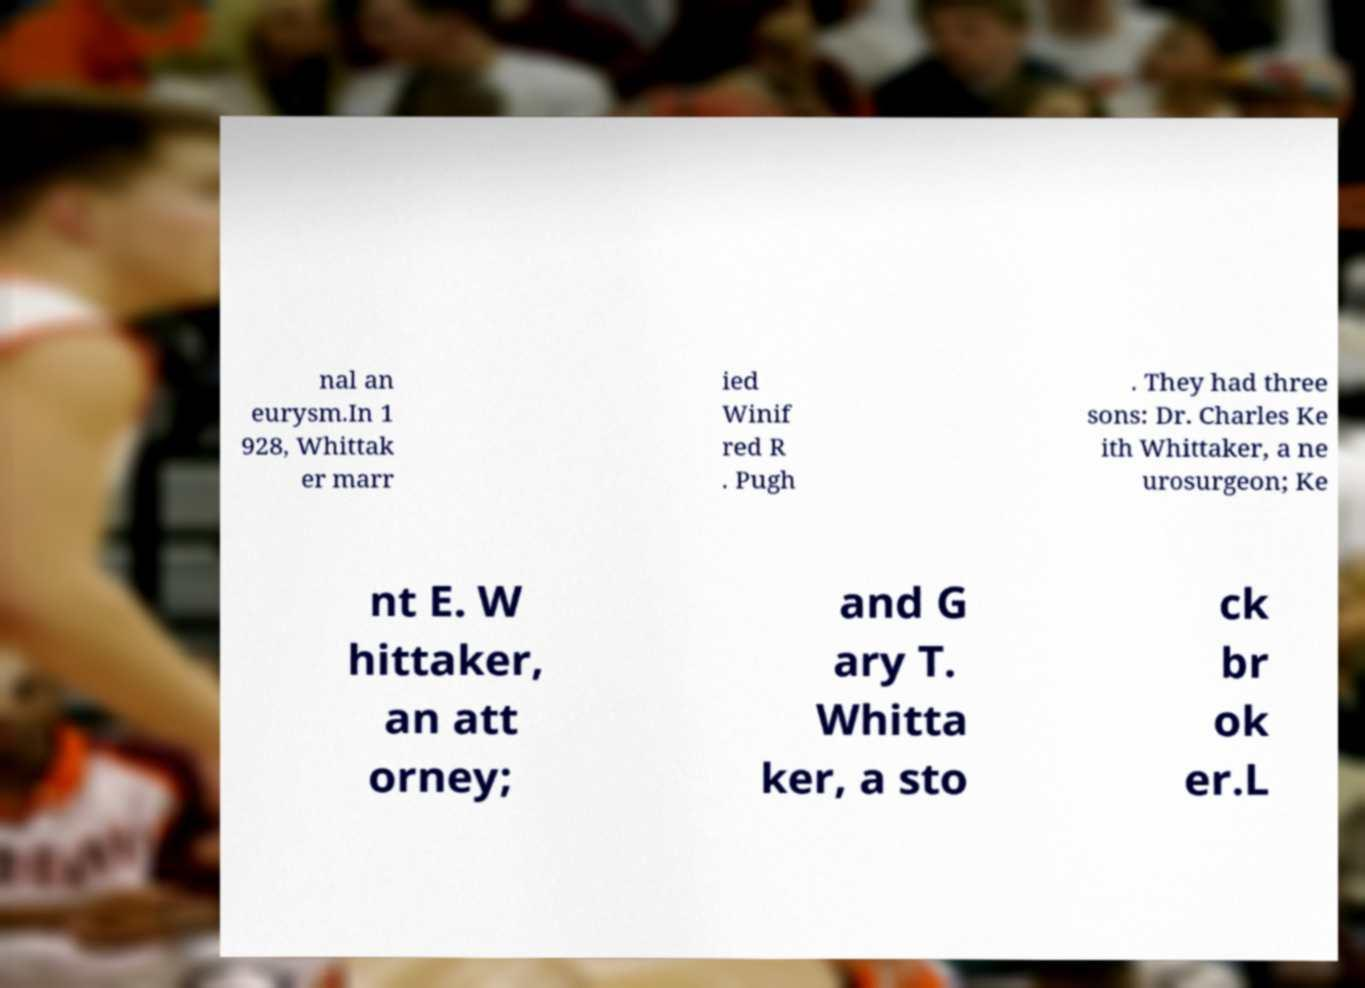There's text embedded in this image that I need extracted. Can you transcribe it verbatim? nal an eurysm.In 1 928, Whittak er marr ied Winif red R . Pugh . They had three sons: Dr. Charles Ke ith Whittaker, a ne urosurgeon; Ke nt E. W hittaker, an att orney; and G ary T. Whitta ker, a sto ck br ok er.L 